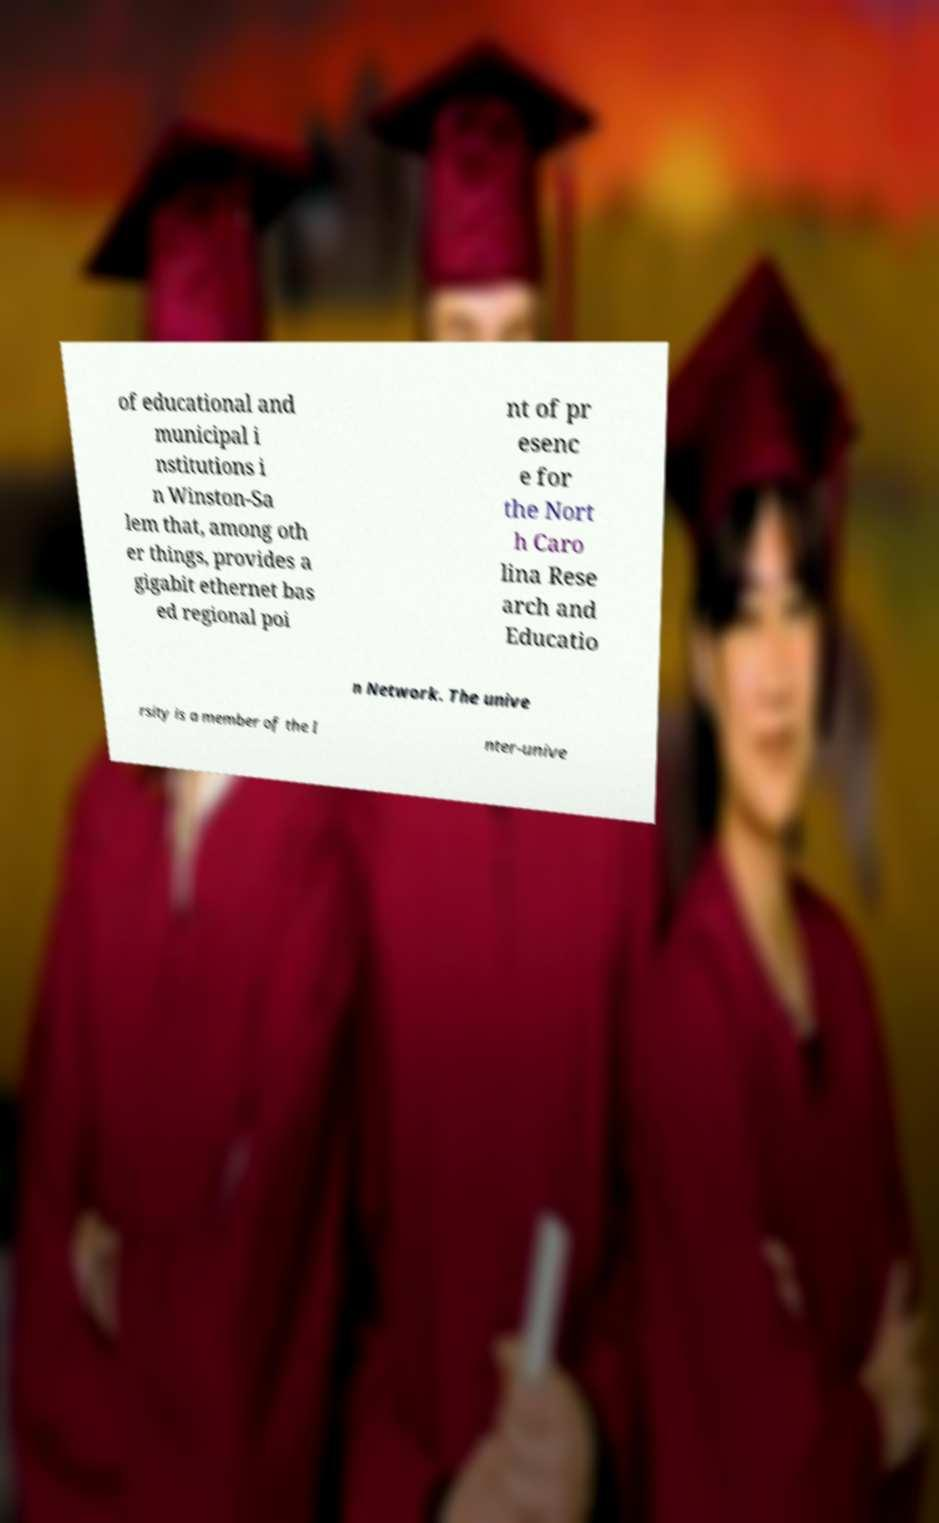Please read and relay the text visible in this image. What does it say? of educational and municipal i nstitutions i n Winston-Sa lem that, among oth er things, provides a gigabit ethernet bas ed regional poi nt of pr esenc e for the Nort h Caro lina Rese arch and Educatio n Network. The unive rsity is a member of the I nter-unive 